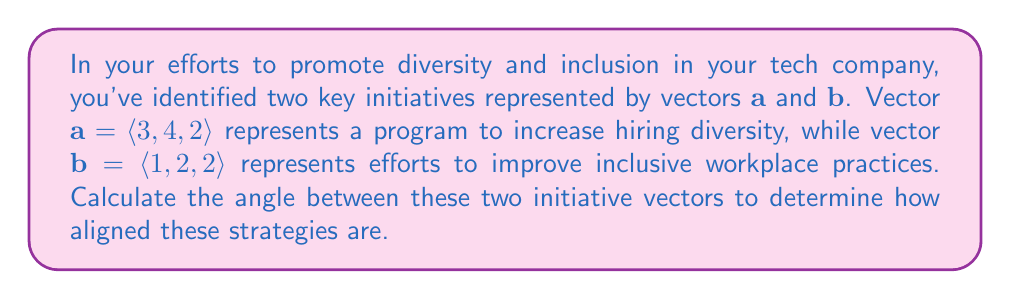Can you solve this math problem? To find the angle between two vectors, we can use the dot product formula:

$$\cos \theta = \frac{\mathbf{a} \cdot \mathbf{b}}{|\mathbf{a}||\mathbf{b}|}$$

Where $\mathbf{a} \cdot \mathbf{b}$ is the dot product of the vectors, and $|\mathbf{a}|$ and $|\mathbf{b}|$ are the magnitudes of vectors $\mathbf{a}$ and $\mathbf{b}$ respectively.

Step 1: Calculate the dot product $\mathbf{a} \cdot \mathbf{b}$
$$\mathbf{a} \cdot \mathbf{b} = (3)(1) + (4)(2) + (2)(2) = 3 + 8 + 4 = 15$$

Step 2: Calculate the magnitudes of $\mathbf{a}$ and $\mathbf{b}$
$$|\mathbf{a}| = \sqrt{3^2 + 4^2 + 2^2} = \sqrt{9 + 16 + 4} = \sqrt{29}$$
$$|\mathbf{b}| = \sqrt{1^2 + 2^2 + 2^2} = \sqrt{1 + 4 + 4} = 3$$

Step 3: Substitute into the formula
$$\cos \theta = \frac{15}{\sqrt{29} \cdot 3}$$

Step 4: Simplify
$$\cos \theta = \frac{15}{3\sqrt{29}} = \frac{5}{\sqrt{29}}$$

Step 5: Take the inverse cosine (arccos) of both sides
$$\theta = \arccos\left(\frac{5}{\sqrt{29}}\right)$$

Step 6: Calculate the result (rounded to two decimal places)
$$\theta \approx 0.81 \text{ radians} \approx 46.41°$$
Answer: The angle between the two initiative vectors is approximately 46.41°. 